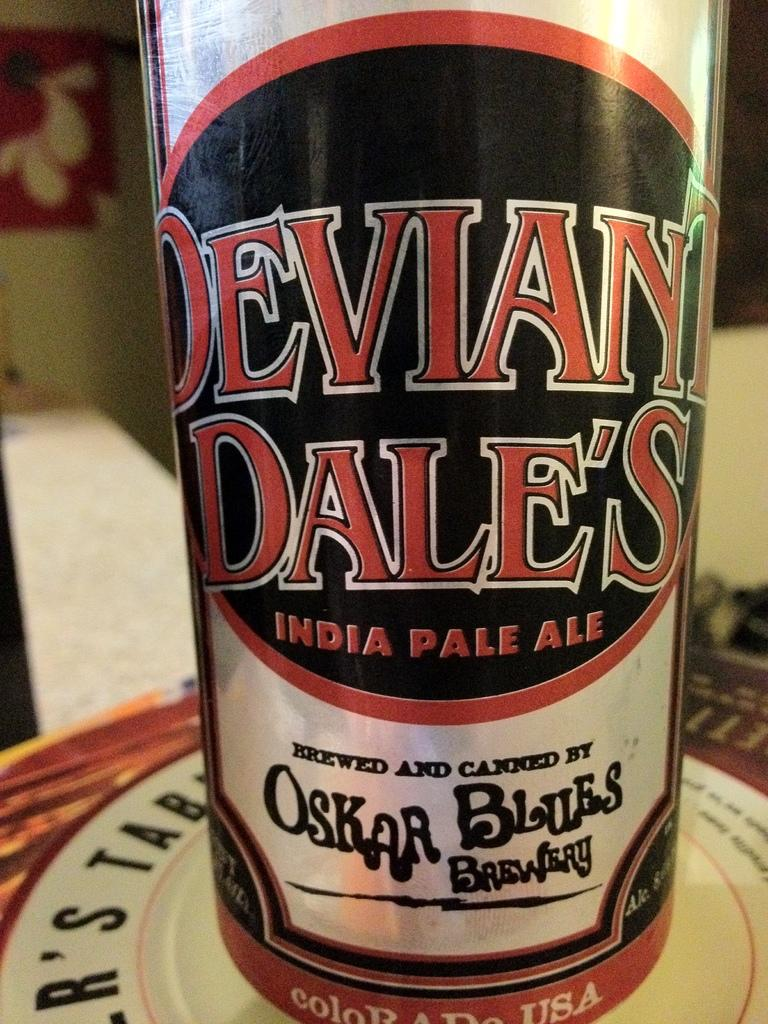What can be seen in the image that is used for holding liquids? There is a bottle in the image that is used for holding liquids. What is on the surface of the bottle? The bottle is covered by a label. What is the bottle resting on? The bottle is on an object. How would you describe the background of the image? The background of the image is blurred. What type of clam is featured in the plot of the image? There is no clam or plot present in the image; it features a bottle with a label. 